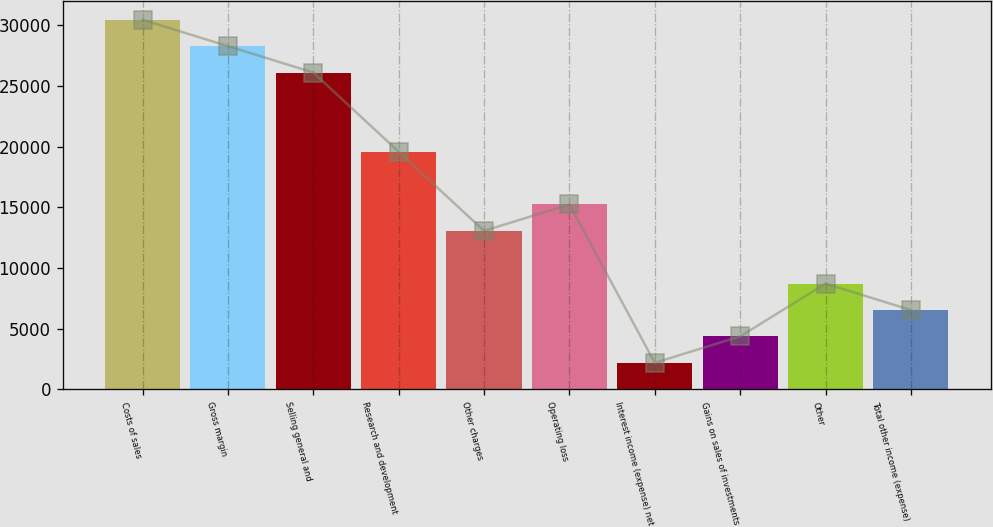<chart> <loc_0><loc_0><loc_500><loc_500><bar_chart><fcel>Costs of sales<fcel>Gross margin<fcel>Selling general and<fcel>Research and development<fcel>Other charges<fcel>Operating loss<fcel>Interest income (expense) net<fcel>Gains on sales of investments<fcel>Other<fcel>Total other income (expense)<nl><fcel>30449.8<fcel>28275.1<fcel>26100.4<fcel>19576.3<fcel>13052.2<fcel>15226.9<fcel>2178.7<fcel>4353.4<fcel>8702.8<fcel>6528.1<nl></chart> 